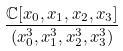Convert formula to latex. <formula><loc_0><loc_0><loc_500><loc_500>\frac { \mathbb { C } [ x _ { 0 } , x _ { 1 } , x _ { 2 } , x _ { 3 } ] } { ( x _ { 0 } ^ { 3 } , x _ { 1 } ^ { 3 } , x _ { 2 } ^ { 3 } , x _ { 3 } ^ { 3 } ) }</formula> 